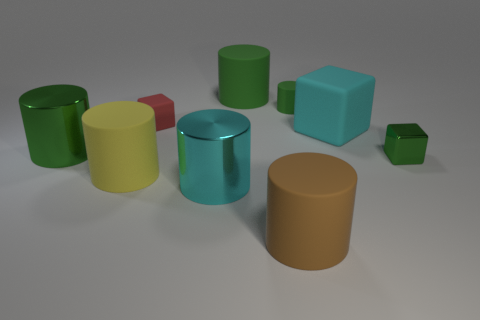Subtract all green cylinders. How many were subtracted if there are1green cylinders left? 2 Subtract all small metal cubes. How many cubes are left? 2 Subtract all red blocks. How many blocks are left? 2 Subtract all blue cylinders. How many gray blocks are left? 0 Subtract all blocks. How many objects are left? 6 Subtract all tiny blue metal cylinders. Subtract all metallic cylinders. How many objects are left? 7 Add 4 small green matte cylinders. How many small green matte cylinders are left? 5 Add 6 small green objects. How many small green objects exist? 8 Add 1 cyan shiny cylinders. How many objects exist? 10 Subtract 0 blue cylinders. How many objects are left? 9 